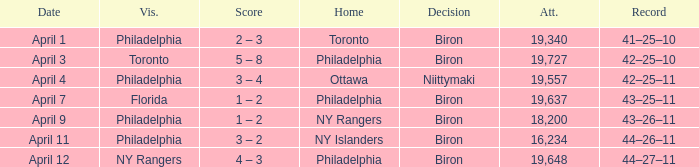I'm looking to parse the entire table for insights. Could you assist me with that? {'header': ['Date', 'Vis.', 'Score', 'Home', 'Decision', 'Att.', 'Record'], 'rows': [['April 1', 'Philadelphia', '2 – 3', 'Toronto', 'Biron', '19,340', '41–25–10'], ['April 3', 'Toronto', '5 – 8', 'Philadelphia', 'Biron', '19,727', '42–25–10'], ['April 4', 'Philadelphia', '3 – 4', 'Ottawa', 'Niittymaki', '19,557', '42–25–11'], ['April 7', 'Florida', '1 – 2', 'Philadelphia', 'Biron', '19,637', '43–25–11'], ['April 9', 'Philadelphia', '1 – 2', 'NY Rangers', 'Biron', '18,200', '43–26–11'], ['April 11', 'Philadelphia', '3 – 2', 'NY Islanders', 'Biron', '16,234', '44–26–11'], ['April 12', 'NY Rangers', '4 – 3', 'Philadelphia', 'Biron', '19,648', '44–27–11']]} What was the flyers' record when the visitors were florida? 43–25–11. 